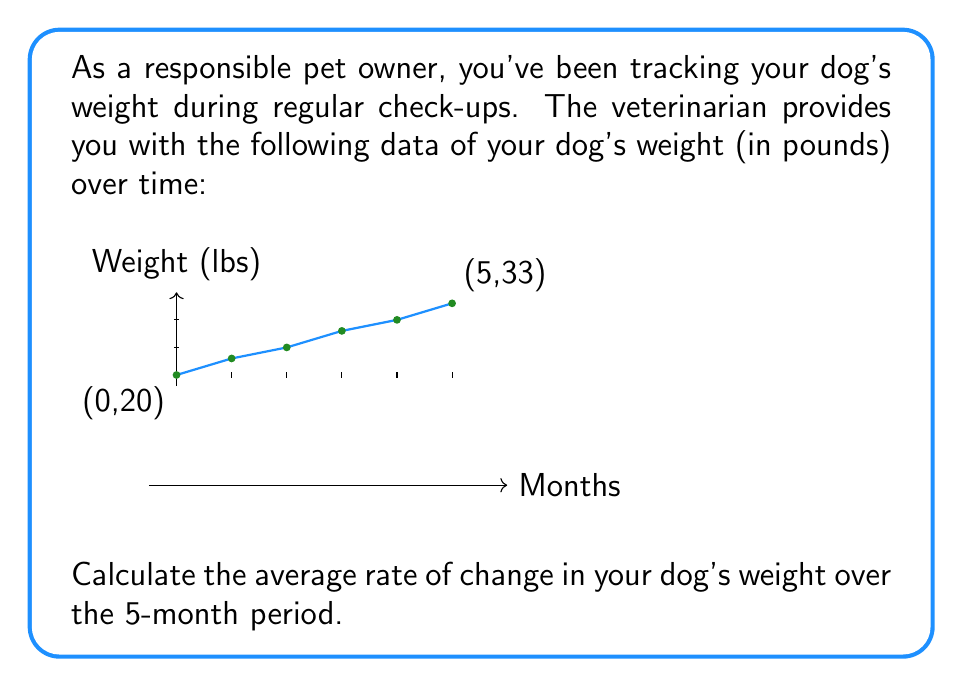Give your solution to this math problem. To calculate the average rate of change, we need to use the formula:

$$ \text{Average rate of change} = \frac{\text{Change in y}}{\text{Change in x}} = \frac{\Delta y}{\Delta x} $$

Let's identify the points:
- Initial point: (0 months, 20 lbs)
- Final point: (5 months, 33 lbs)

Now, let's calculate:

1) Change in y (weight):
   $\Delta y = 33 \text{ lbs} - 20 \text{ lbs} = 13 \text{ lbs}$

2) Change in x (time):
   $\Delta x = 5 \text{ months} - 0 \text{ months} = 5 \text{ months}$

3) Apply the formula:
   $$ \text{Average rate of change} = \frac{\Delta y}{\Delta x} = \frac{13 \text{ lbs}}{5 \text{ months}} = 2.6 \text{ lbs/month} $$

Therefore, the dog's weight increased at an average rate of 2.6 pounds per month over the 5-month period.
Answer: 2.6 lbs/month 